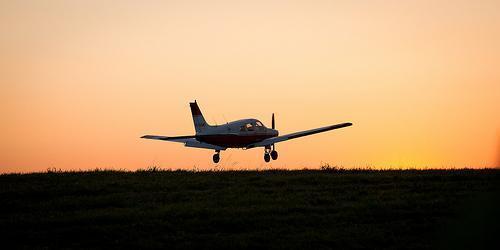How many planes are visible?
Give a very brief answer. 1. How many windows?
Give a very brief answer. 2. How many planes are there?
Give a very brief answer. 1. How many wheels are there?
Give a very brief answer. 3. How many people are standing in the grass?
Give a very brief answer. 0. How many wheels does the plane have?
Give a very brief answer. 3. 